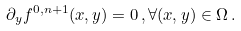Convert formula to latex. <formula><loc_0><loc_0><loc_500><loc_500>\partial _ { y } f ^ { 0 , n + 1 } ( x , y ) = 0 \, , \forall ( x , y ) \in \Omega \, .</formula> 